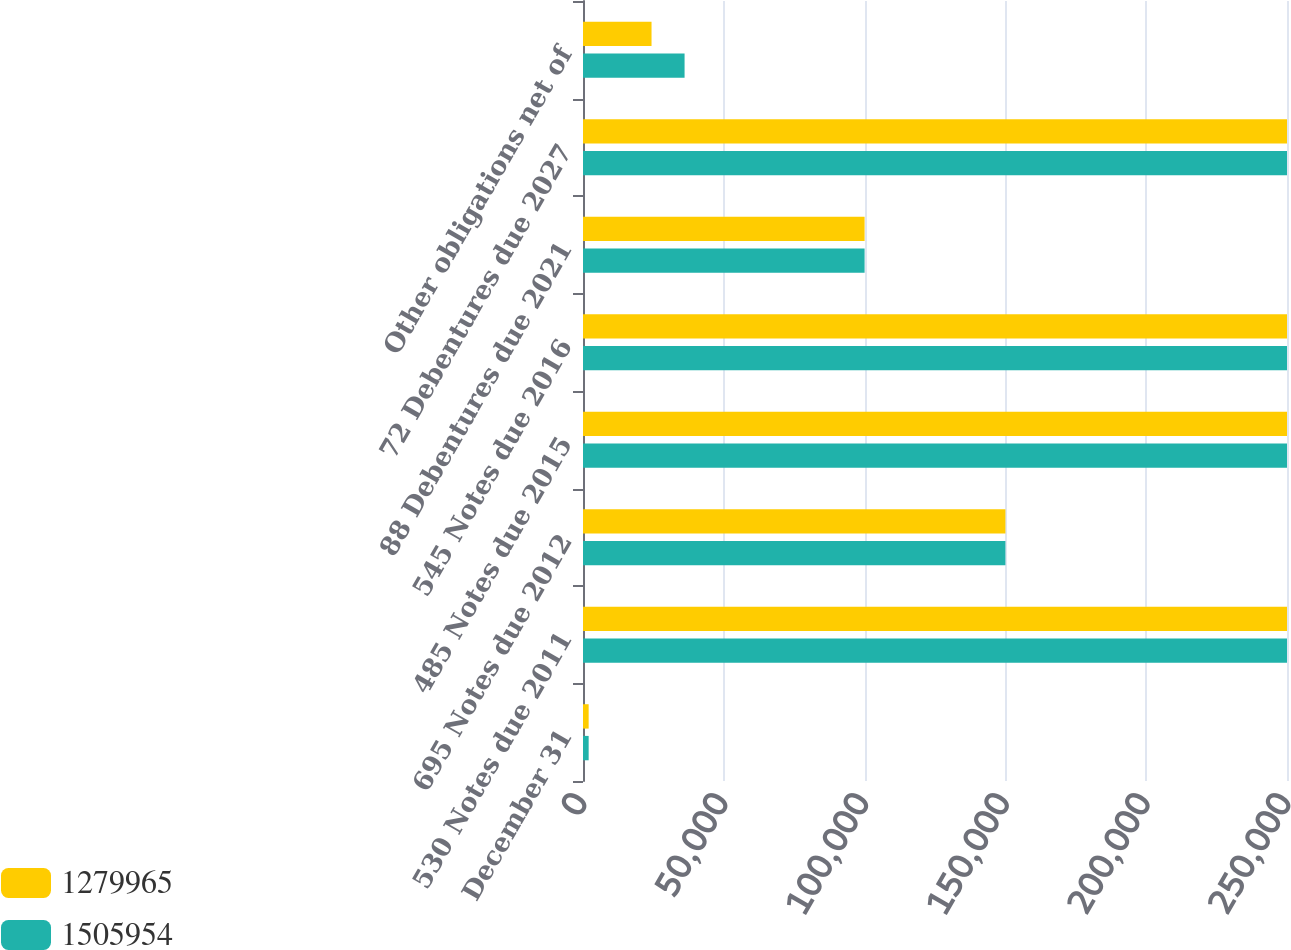Convert chart. <chart><loc_0><loc_0><loc_500><loc_500><stacked_bar_chart><ecel><fcel>December 31<fcel>530 Notes due 2011<fcel>695 Notes due 2012<fcel>485 Notes due 2015<fcel>545 Notes due 2016<fcel>88 Debentures due 2021<fcel>72 Debentures due 2027<fcel>Other obligations net of<nl><fcel>1.27996e+06<fcel>2008<fcel>250000<fcel>150000<fcel>250000<fcel>250000<fcel>100000<fcel>250000<fcel>24338<nl><fcel>1.50595e+06<fcel>2007<fcel>250000<fcel>150000<fcel>250000<fcel>250000<fcel>100000<fcel>250000<fcel>36069<nl></chart> 